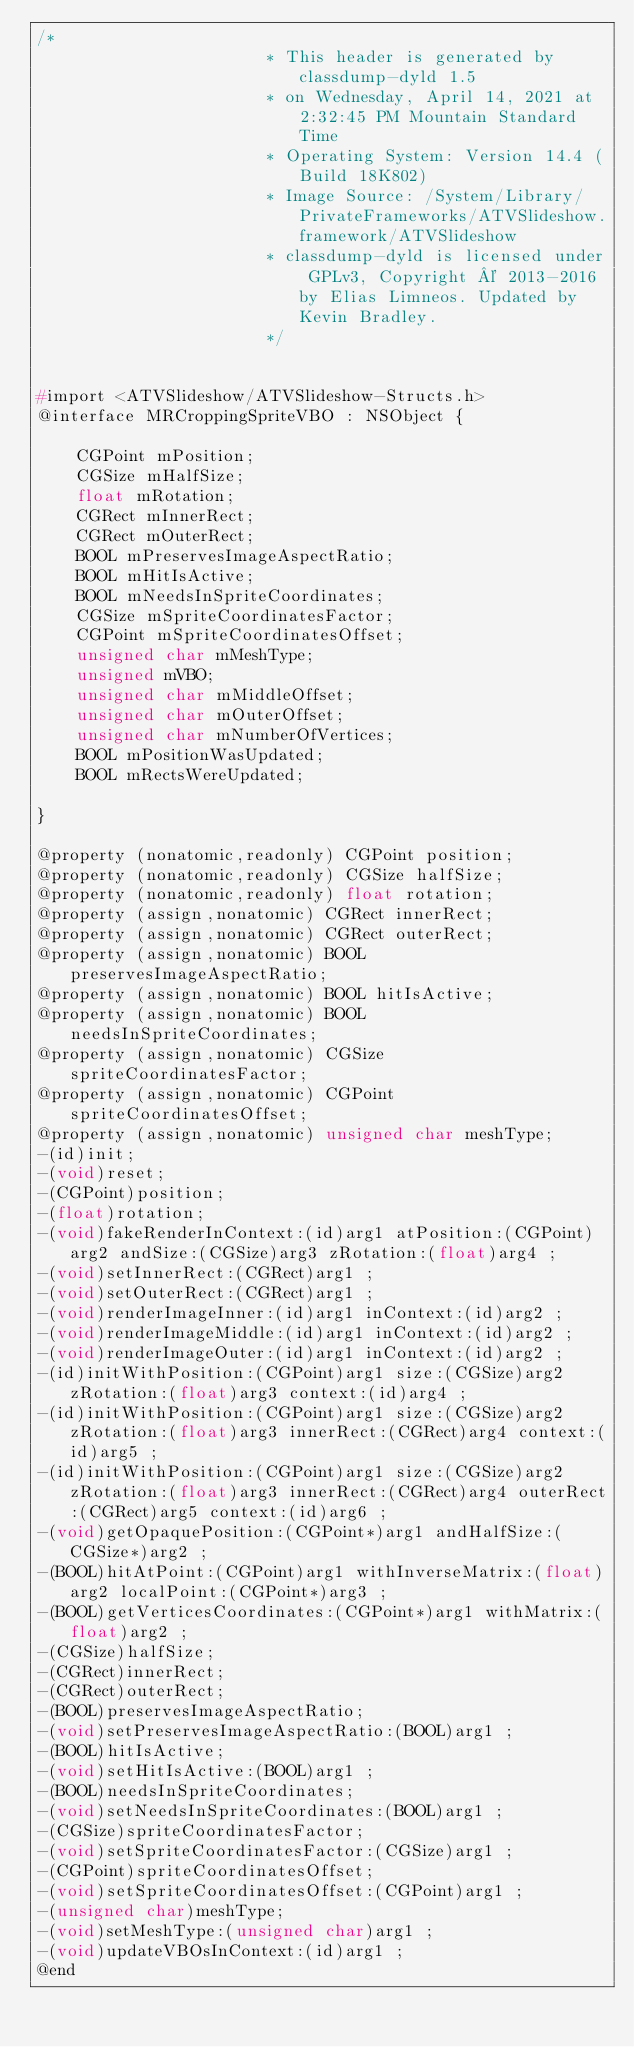<code> <loc_0><loc_0><loc_500><loc_500><_C_>/*
                       * This header is generated by classdump-dyld 1.5
                       * on Wednesday, April 14, 2021 at 2:32:45 PM Mountain Standard Time
                       * Operating System: Version 14.4 (Build 18K802)
                       * Image Source: /System/Library/PrivateFrameworks/ATVSlideshow.framework/ATVSlideshow
                       * classdump-dyld is licensed under GPLv3, Copyright © 2013-2016 by Elias Limneos. Updated by Kevin Bradley.
                       */


#import <ATVSlideshow/ATVSlideshow-Structs.h>
@interface MRCroppingSpriteVBO : NSObject {

	CGPoint mPosition;
	CGSize mHalfSize;
	float mRotation;
	CGRect mInnerRect;
	CGRect mOuterRect;
	BOOL mPreservesImageAspectRatio;
	BOOL mHitIsActive;
	BOOL mNeedsInSpriteCoordinates;
	CGSize mSpriteCoordinatesFactor;
	CGPoint mSpriteCoordinatesOffset;
	unsigned char mMeshType;
	unsigned mVBO;
	unsigned char mMiddleOffset;
	unsigned char mOuterOffset;
	unsigned char mNumberOfVertices;
	BOOL mPositionWasUpdated;
	BOOL mRectsWereUpdated;

}

@property (nonatomic,readonly) CGPoint position; 
@property (nonatomic,readonly) CGSize halfSize; 
@property (nonatomic,readonly) float rotation; 
@property (assign,nonatomic) CGRect innerRect; 
@property (assign,nonatomic) CGRect outerRect; 
@property (assign,nonatomic) BOOL preservesImageAspectRatio; 
@property (assign,nonatomic) BOOL hitIsActive; 
@property (assign,nonatomic) BOOL needsInSpriteCoordinates; 
@property (assign,nonatomic) CGSize spriteCoordinatesFactor; 
@property (assign,nonatomic) CGPoint spriteCoordinatesOffset; 
@property (assign,nonatomic) unsigned char meshType; 
-(id)init;
-(void)reset;
-(CGPoint)position;
-(float)rotation;
-(void)fakeRenderInContext:(id)arg1 atPosition:(CGPoint)arg2 andSize:(CGSize)arg3 zRotation:(float)arg4 ;
-(void)setInnerRect:(CGRect)arg1 ;
-(void)setOuterRect:(CGRect)arg1 ;
-(void)renderImageInner:(id)arg1 inContext:(id)arg2 ;
-(void)renderImageMiddle:(id)arg1 inContext:(id)arg2 ;
-(void)renderImageOuter:(id)arg1 inContext:(id)arg2 ;
-(id)initWithPosition:(CGPoint)arg1 size:(CGSize)arg2 zRotation:(float)arg3 context:(id)arg4 ;
-(id)initWithPosition:(CGPoint)arg1 size:(CGSize)arg2 zRotation:(float)arg3 innerRect:(CGRect)arg4 context:(id)arg5 ;
-(id)initWithPosition:(CGPoint)arg1 size:(CGSize)arg2 zRotation:(float)arg3 innerRect:(CGRect)arg4 outerRect:(CGRect)arg5 context:(id)arg6 ;
-(void)getOpaquePosition:(CGPoint*)arg1 andHalfSize:(CGSize*)arg2 ;
-(BOOL)hitAtPoint:(CGPoint)arg1 withInverseMatrix:(float)arg2 localPoint:(CGPoint*)arg3 ;
-(BOOL)getVerticesCoordinates:(CGPoint*)arg1 withMatrix:(float)arg2 ;
-(CGSize)halfSize;
-(CGRect)innerRect;
-(CGRect)outerRect;
-(BOOL)preservesImageAspectRatio;
-(void)setPreservesImageAspectRatio:(BOOL)arg1 ;
-(BOOL)hitIsActive;
-(void)setHitIsActive:(BOOL)arg1 ;
-(BOOL)needsInSpriteCoordinates;
-(void)setNeedsInSpriteCoordinates:(BOOL)arg1 ;
-(CGSize)spriteCoordinatesFactor;
-(void)setSpriteCoordinatesFactor:(CGSize)arg1 ;
-(CGPoint)spriteCoordinatesOffset;
-(void)setSpriteCoordinatesOffset:(CGPoint)arg1 ;
-(unsigned char)meshType;
-(void)setMeshType:(unsigned char)arg1 ;
-(void)updateVBOsInContext:(id)arg1 ;
@end

</code> 